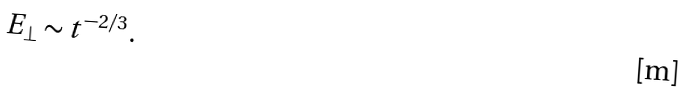<formula> <loc_0><loc_0><loc_500><loc_500>E _ { \perp } \sim t ^ { - 2 / 3 } .</formula> 